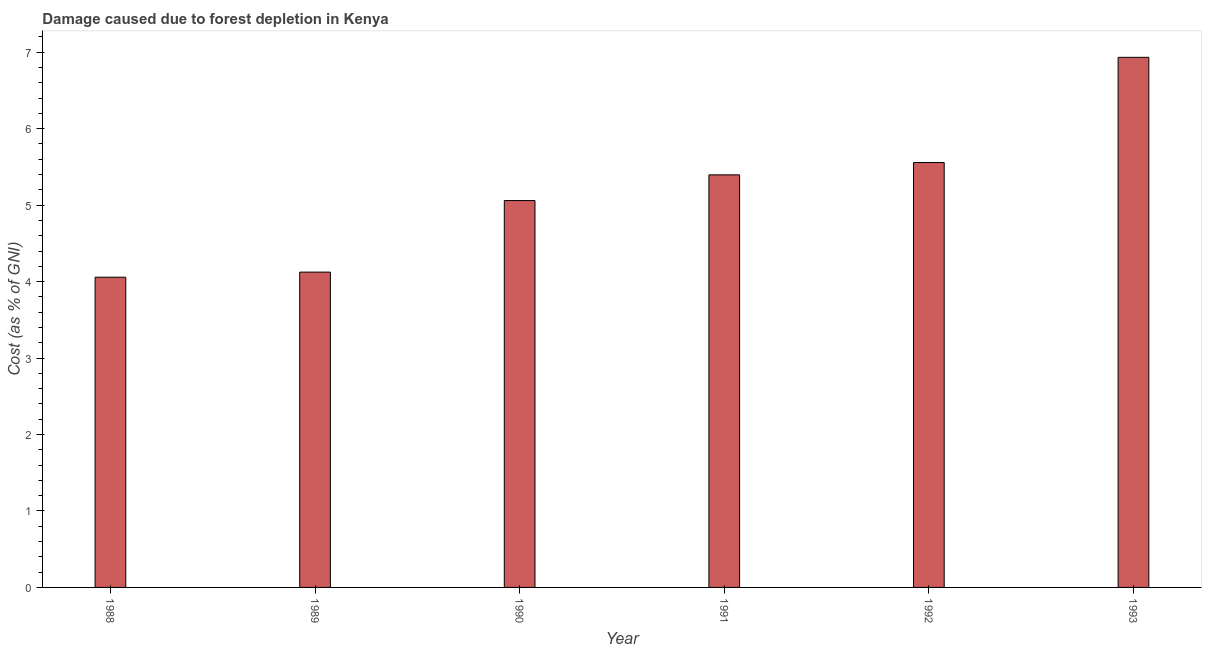Does the graph contain any zero values?
Provide a succinct answer. No. Does the graph contain grids?
Your answer should be very brief. No. What is the title of the graph?
Offer a very short reply. Damage caused due to forest depletion in Kenya. What is the label or title of the X-axis?
Ensure brevity in your answer.  Year. What is the label or title of the Y-axis?
Your response must be concise. Cost (as % of GNI). What is the damage caused due to forest depletion in 1992?
Provide a succinct answer. 5.56. Across all years, what is the maximum damage caused due to forest depletion?
Offer a terse response. 6.93. Across all years, what is the minimum damage caused due to forest depletion?
Offer a very short reply. 4.06. In which year was the damage caused due to forest depletion maximum?
Offer a terse response. 1993. In which year was the damage caused due to forest depletion minimum?
Offer a very short reply. 1988. What is the sum of the damage caused due to forest depletion?
Keep it short and to the point. 31.13. What is the difference between the damage caused due to forest depletion in 1990 and 1992?
Your answer should be compact. -0.5. What is the average damage caused due to forest depletion per year?
Offer a very short reply. 5.19. What is the median damage caused due to forest depletion?
Offer a terse response. 5.23. In how many years, is the damage caused due to forest depletion greater than 4 %?
Offer a very short reply. 6. What is the ratio of the damage caused due to forest depletion in 1989 to that in 1991?
Give a very brief answer. 0.76. What is the difference between the highest and the second highest damage caused due to forest depletion?
Give a very brief answer. 1.38. What is the difference between the highest and the lowest damage caused due to forest depletion?
Provide a short and direct response. 2.88. What is the difference between two consecutive major ticks on the Y-axis?
Your response must be concise. 1. What is the Cost (as % of GNI) in 1988?
Provide a short and direct response. 4.06. What is the Cost (as % of GNI) of 1989?
Your answer should be compact. 4.12. What is the Cost (as % of GNI) of 1990?
Offer a very short reply. 5.06. What is the Cost (as % of GNI) in 1991?
Your answer should be very brief. 5.4. What is the Cost (as % of GNI) of 1992?
Ensure brevity in your answer.  5.56. What is the Cost (as % of GNI) in 1993?
Ensure brevity in your answer.  6.93. What is the difference between the Cost (as % of GNI) in 1988 and 1989?
Offer a very short reply. -0.07. What is the difference between the Cost (as % of GNI) in 1988 and 1990?
Ensure brevity in your answer.  -1. What is the difference between the Cost (as % of GNI) in 1988 and 1991?
Your response must be concise. -1.34. What is the difference between the Cost (as % of GNI) in 1988 and 1992?
Your answer should be compact. -1.5. What is the difference between the Cost (as % of GNI) in 1988 and 1993?
Your response must be concise. -2.88. What is the difference between the Cost (as % of GNI) in 1989 and 1990?
Make the answer very short. -0.94. What is the difference between the Cost (as % of GNI) in 1989 and 1991?
Your answer should be very brief. -1.27. What is the difference between the Cost (as % of GNI) in 1989 and 1992?
Provide a short and direct response. -1.43. What is the difference between the Cost (as % of GNI) in 1989 and 1993?
Offer a terse response. -2.81. What is the difference between the Cost (as % of GNI) in 1990 and 1991?
Ensure brevity in your answer.  -0.34. What is the difference between the Cost (as % of GNI) in 1990 and 1992?
Offer a terse response. -0.5. What is the difference between the Cost (as % of GNI) in 1990 and 1993?
Your answer should be very brief. -1.87. What is the difference between the Cost (as % of GNI) in 1991 and 1992?
Give a very brief answer. -0.16. What is the difference between the Cost (as % of GNI) in 1991 and 1993?
Offer a terse response. -1.54. What is the difference between the Cost (as % of GNI) in 1992 and 1993?
Provide a short and direct response. -1.38. What is the ratio of the Cost (as % of GNI) in 1988 to that in 1989?
Provide a succinct answer. 0.98. What is the ratio of the Cost (as % of GNI) in 1988 to that in 1990?
Your response must be concise. 0.8. What is the ratio of the Cost (as % of GNI) in 1988 to that in 1991?
Your response must be concise. 0.75. What is the ratio of the Cost (as % of GNI) in 1988 to that in 1992?
Offer a very short reply. 0.73. What is the ratio of the Cost (as % of GNI) in 1988 to that in 1993?
Your answer should be very brief. 0.58. What is the ratio of the Cost (as % of GNI) in 1989 to that in 1990?
Keep it short and to the point. 0.81. What is the ratio of the Cost (as % of GNI) in 1989 to that in 1991?
Keep it short and to the point. 0.76. What is the ratio of the Cost (as % of GNI) in 1989 to that in 1992?
Give a very brief answer. 0.74. What is the ratio of the Cost (as % of GNI) in 1989 to that in 1993?
Offer a very short reply. 0.59. What is the ratio of the Cost (as % of GNI) in 1990 to that in 1991?
Make the answer very short. 0.94. What is the ratio of the Cost (as % of GNI) in 1990 to that in 1992?
Offer a very short reply. 0.91. What is the ratio of the Cost (as % of GNI) in 1990 to that in 1993?
Provide a short and direct response. 0.73. What is the ratio of the Cost (as % of GNI) in 1991 to that in 1993?
Make the answer very short. 0.78. What is the ratio of the Cost (as % of GNI) in 1992 to that in 1993?
Your answer should be very brief. 0.8. 